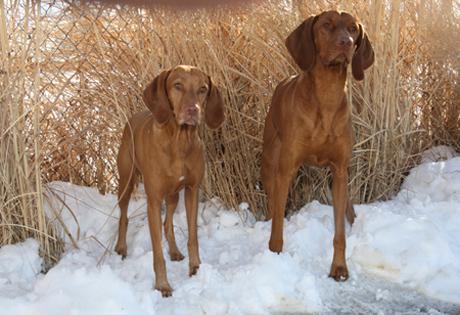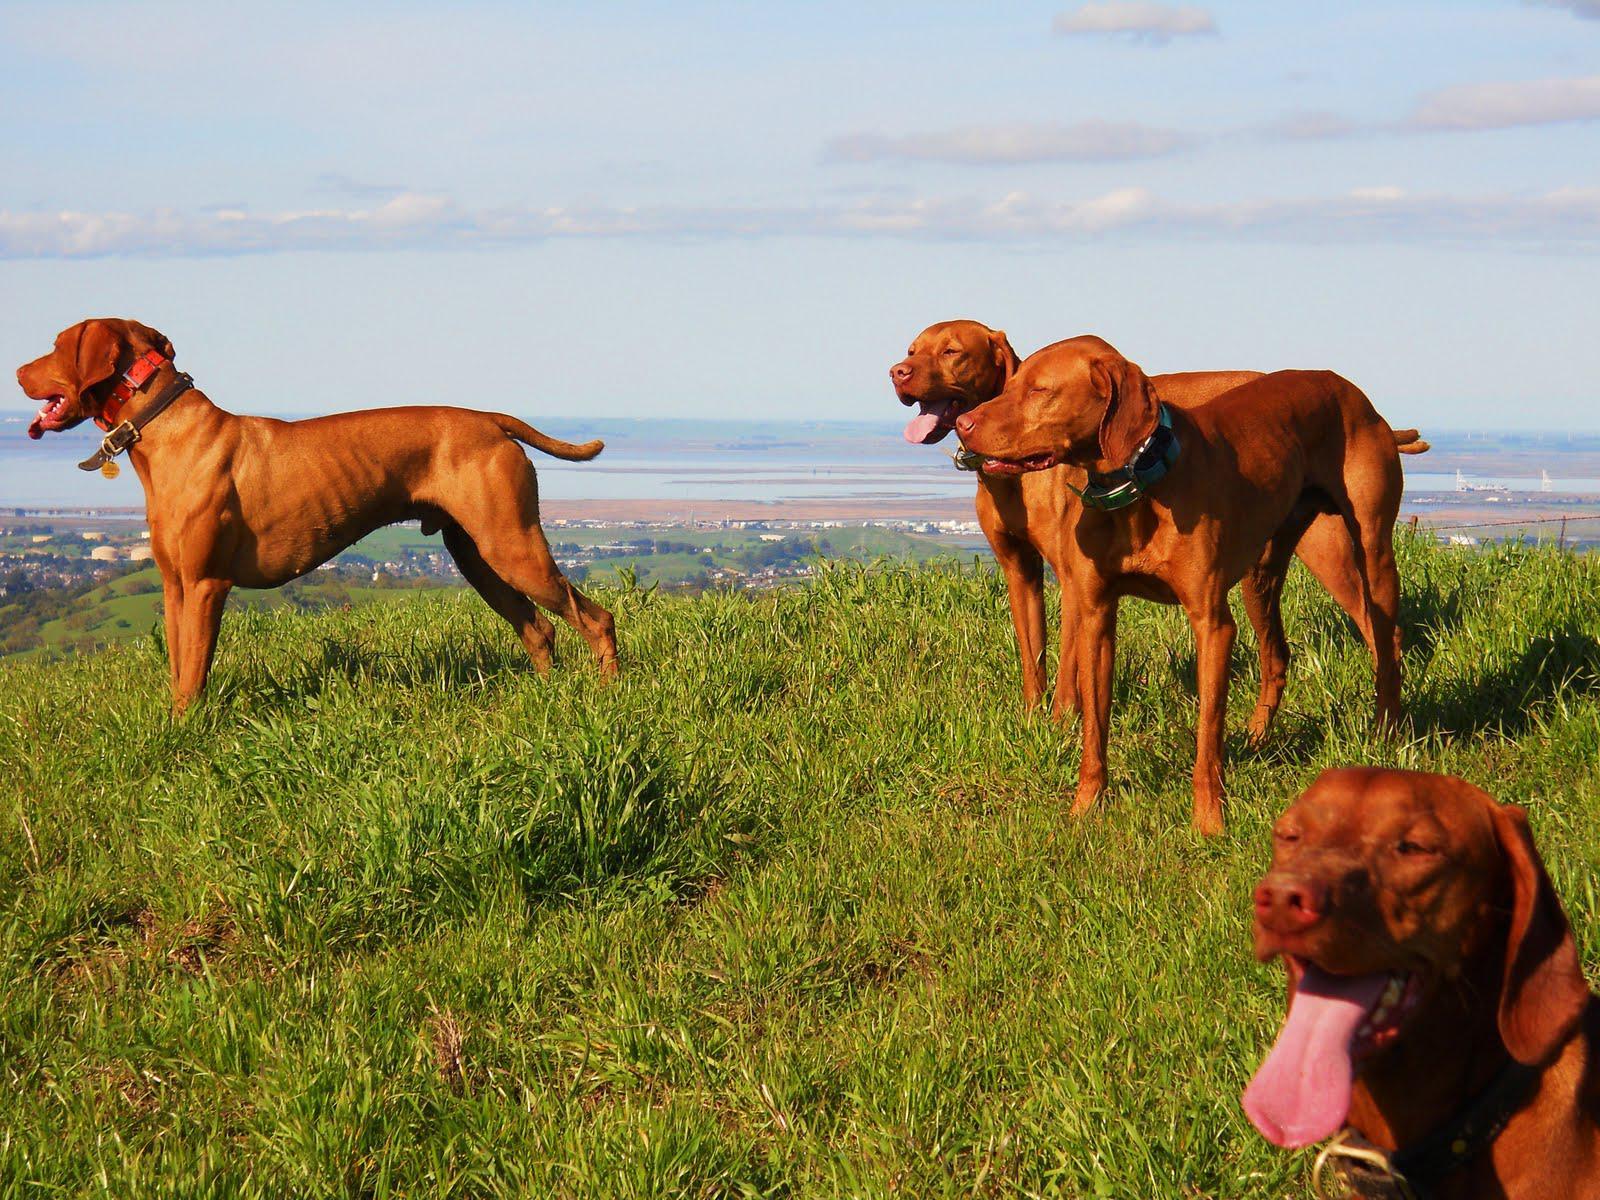The first image is the image on the left, the second image is the image on the right. Considering the images on both sides, is "In the right image, there's a single Vizsla facing the right." valid? Answer yes or no. No. The first image is the image on the left, the second image is the image on the right. Evaluate the accuracy of this statement regarding the images: "There are at least four dogs in total.". Is it true? Answer yes or no. Yes. 